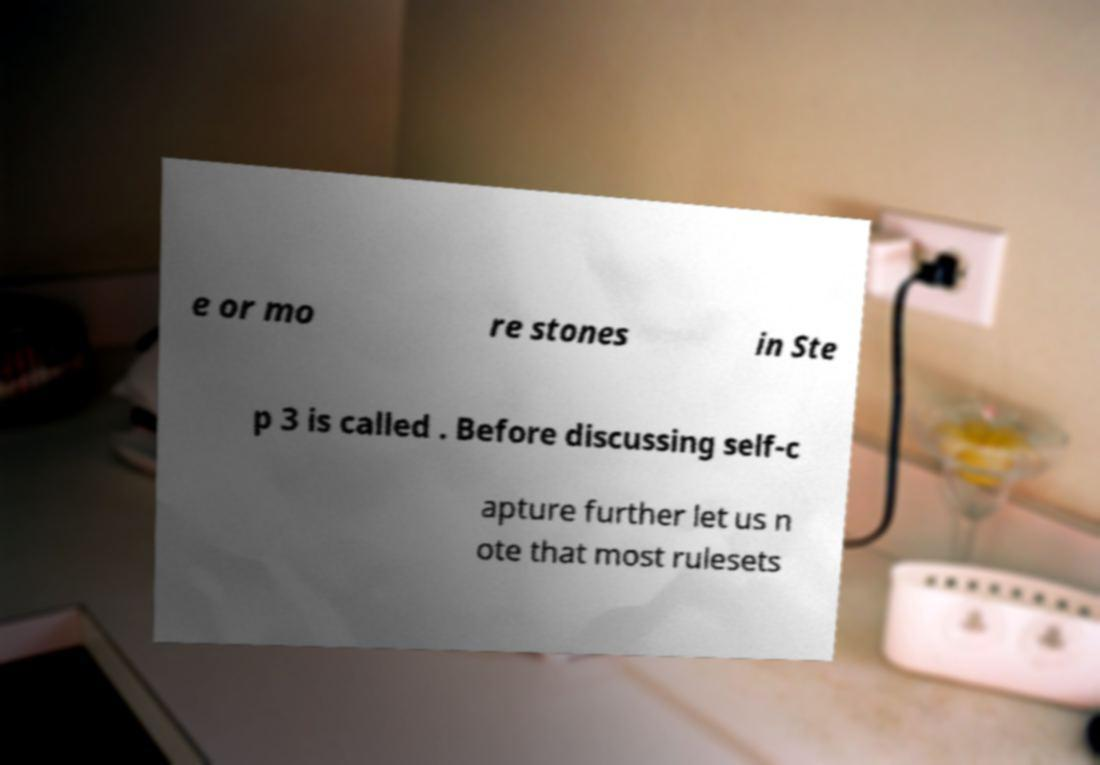What messages or text are displayed in this image? I need them in a readable, typed format. e or mo re stones in Ste p 3 is called . Before discussing self-c apture further let us n ote that most rulesets 